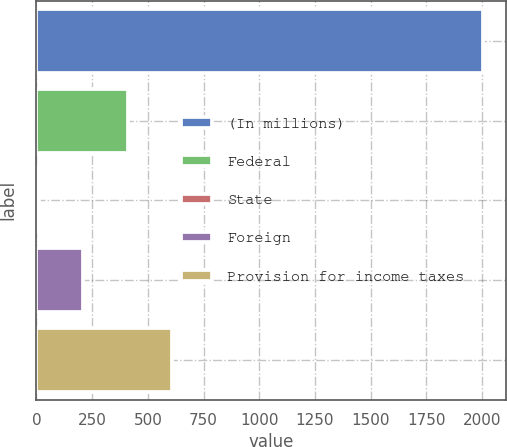Convert chart to OTSL. <chart><loc_0><loc_0><loc_500><loc_500><bar_chart><fcel>(In millions)<fcel>Federal<fcel>State<fcel>Foreign<fcel>Provision for income taxes<nl><fcel>2005<fcel>409.16<fcel>10.2<fcel>209.68<fcel>608.64<nl></chart> 